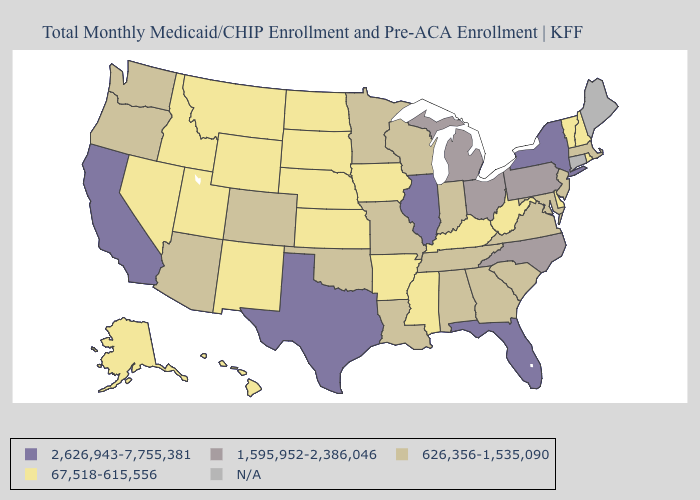What is the value of North Dakota?
Answer briefly. 67,518-615,556. What is the lowest value in the Northeast?
Keep it brief. 67,518-615,556. Does the map have missing data?
Short answer required. Yes. Which states hav the highest value in the MidWest?
Answer briefly. Illinois. What is the lowest value in states that border Missouri?
Quick response, please. 67,518-615,556. What is the value of Indiana?
Answer briefly. 626,356-1,535,090. Name the states that have a value in the range 1,595,952-2,386,046?
Answer briefly. Michigan, North Carolina, Ohio, Pennsylvania. What is the value of Utah?
Be succinct. 67,518-615,556. Does Utah have the lowest value in the West?
Give a very brief answer. Yes. What is the value of Arkansas?
Answer briefly. 67,518-615,556. Name the states that have a value in the range 626,356-1,535,090?
Concise answer only. Alabama, Arizona, Colorado, Georgia, Indiana, Louisiana, Maryland, Massachusetts, Minnesota, Missouri, New Jersey, Oklahoma, Oregon, South Carolina, Tennessee, Virginia, Washington, Wisconsin. What is the value of Hawaii?
Answer briefly. 67,518-615,556. Among the states that border Ohio , which have the highest value?
Give a very brief answer. Michigan, Pennsylvania. Does Arizona have the lowest value in the West?
Be succinct. No. 